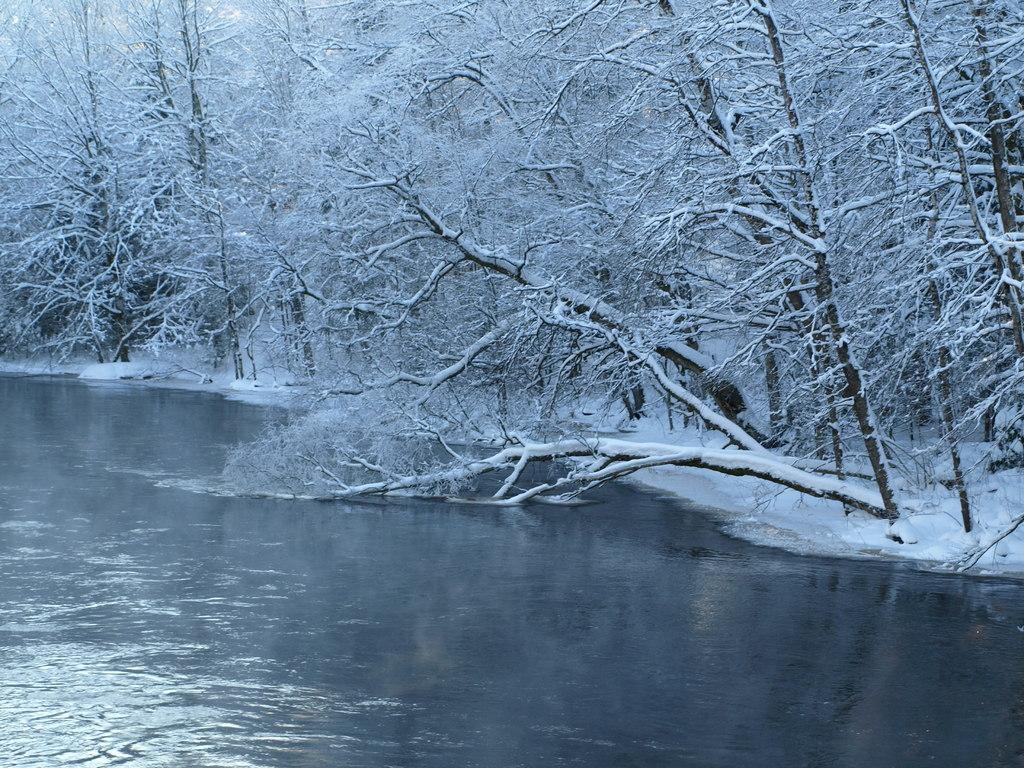What type of vegetation is present in the image? There are trees in the image. What natural element can be seen alongside the trees? There is water visible in the image. Can you describe a specific tree in the image? Yes, there is a tree bent into the water in the image. How many legs are visible on the canvas in the image? There is no canvas present in the image, and therefore no legs can be seen on it. 